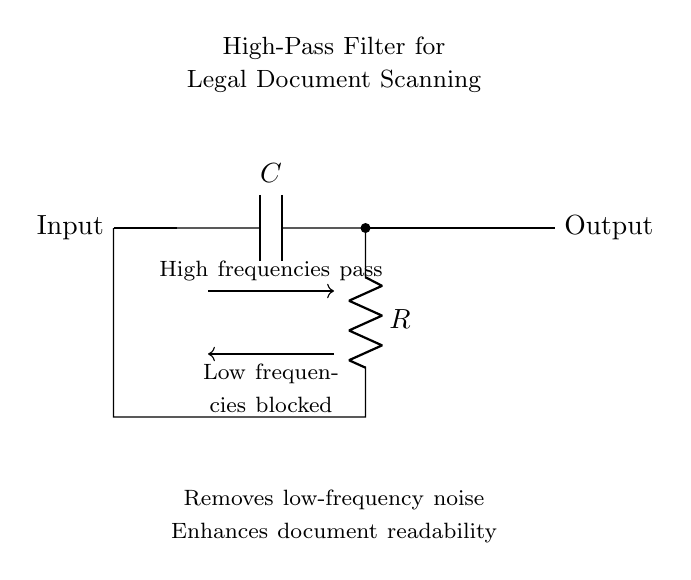What is the primary function of this circuit? The circuit functions as a high-pass filter, which allows high frequencies to pass while blocking low frequencies, specifically designed to enhance document readability.
Answer: high-pass filter What is the component labeled "C"? The component labeled "C" is a capacitor, which is a key element in high-pass filter circuits, allowing high-frequency signals to bypass while impeding low-frequency signals.
Answer: capacitor What does the label "R" represent? The label "R" represents a resistor, which works in conjunction with the capacitor to determine the cutoff frequency of the high-pass filter.
Answer: resistor What type of signals does this circuit block? This circuit blocks low-frequency signals, specifically those below the cutoff frequency, which may include noise that reduces readability in scanned legal documents.
Answer: low-frequency signals What happens to high-frequency signals in this circuit? High-frequency signals are allowed to pass through the circuit, which is crucial for maintaining the clarity and readability of the scanned legal documents.
Answer: allowed to pass What is the overall objective of using this high-pass filter in document scanning? The overall objective is to remove low-frequency noise from scanned legal documents to enhance their readability, making them clearer for analysis and review.
Answer: enhance readability What is the impact of the capacitor on the performance of this circuit? The capacitor affects the cutoff frequency and the filtering characteristics, allowing the circuit to selectively filter out low frequencies, thus improving the quality of the scanned documents.
Answer: affects cutoff frequency 